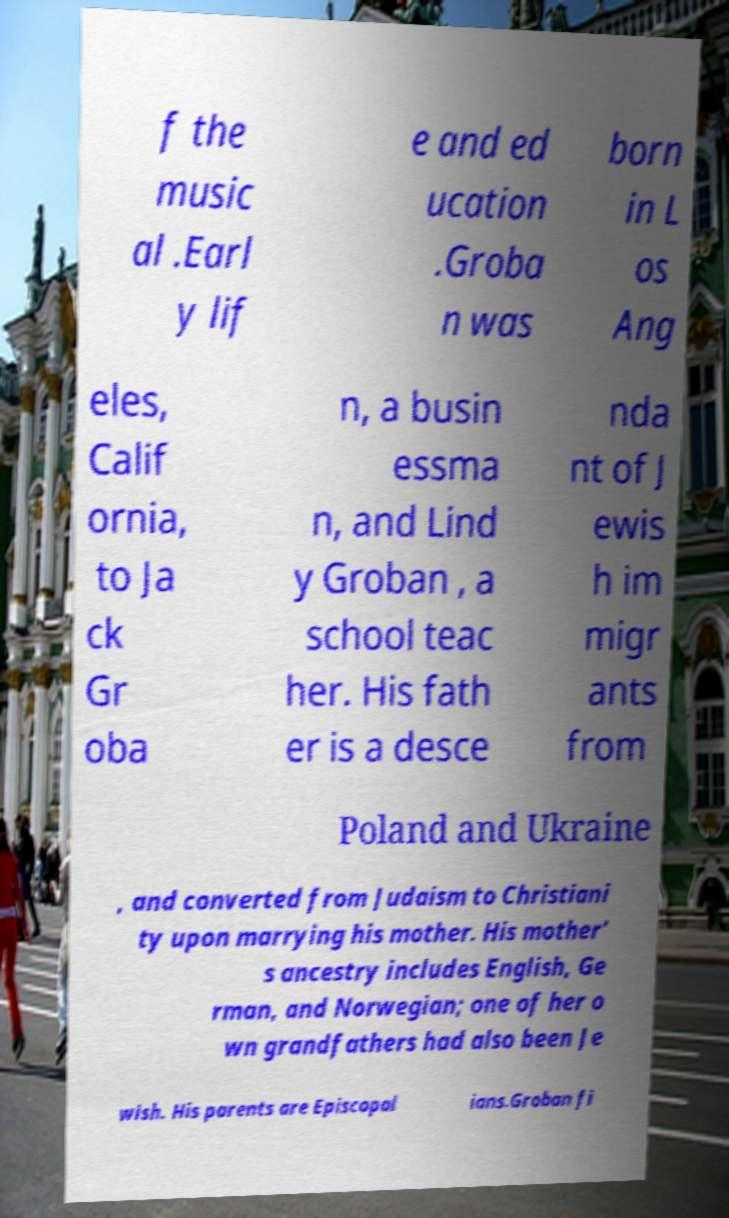Could you extract and type out the text from this image? f the music al .Earl y lif e and ed ucation .Groba n was born in L os Ang eles, Calif ornia, to Ja ck Gr oba n, a busin essma n, and Lind y Groban , a school teac her. His fath er is a desce nda nt of J ewis h im migr ants from Poland and Ukraine , and converted from Judaism to Christiani ty upon marrying his mother. His mother' s ancestry includes English, Ge rman, and Norwegian; one of her o wn grandfathers had also been Je wish. His parents are Episcopal ians.Groban fi 